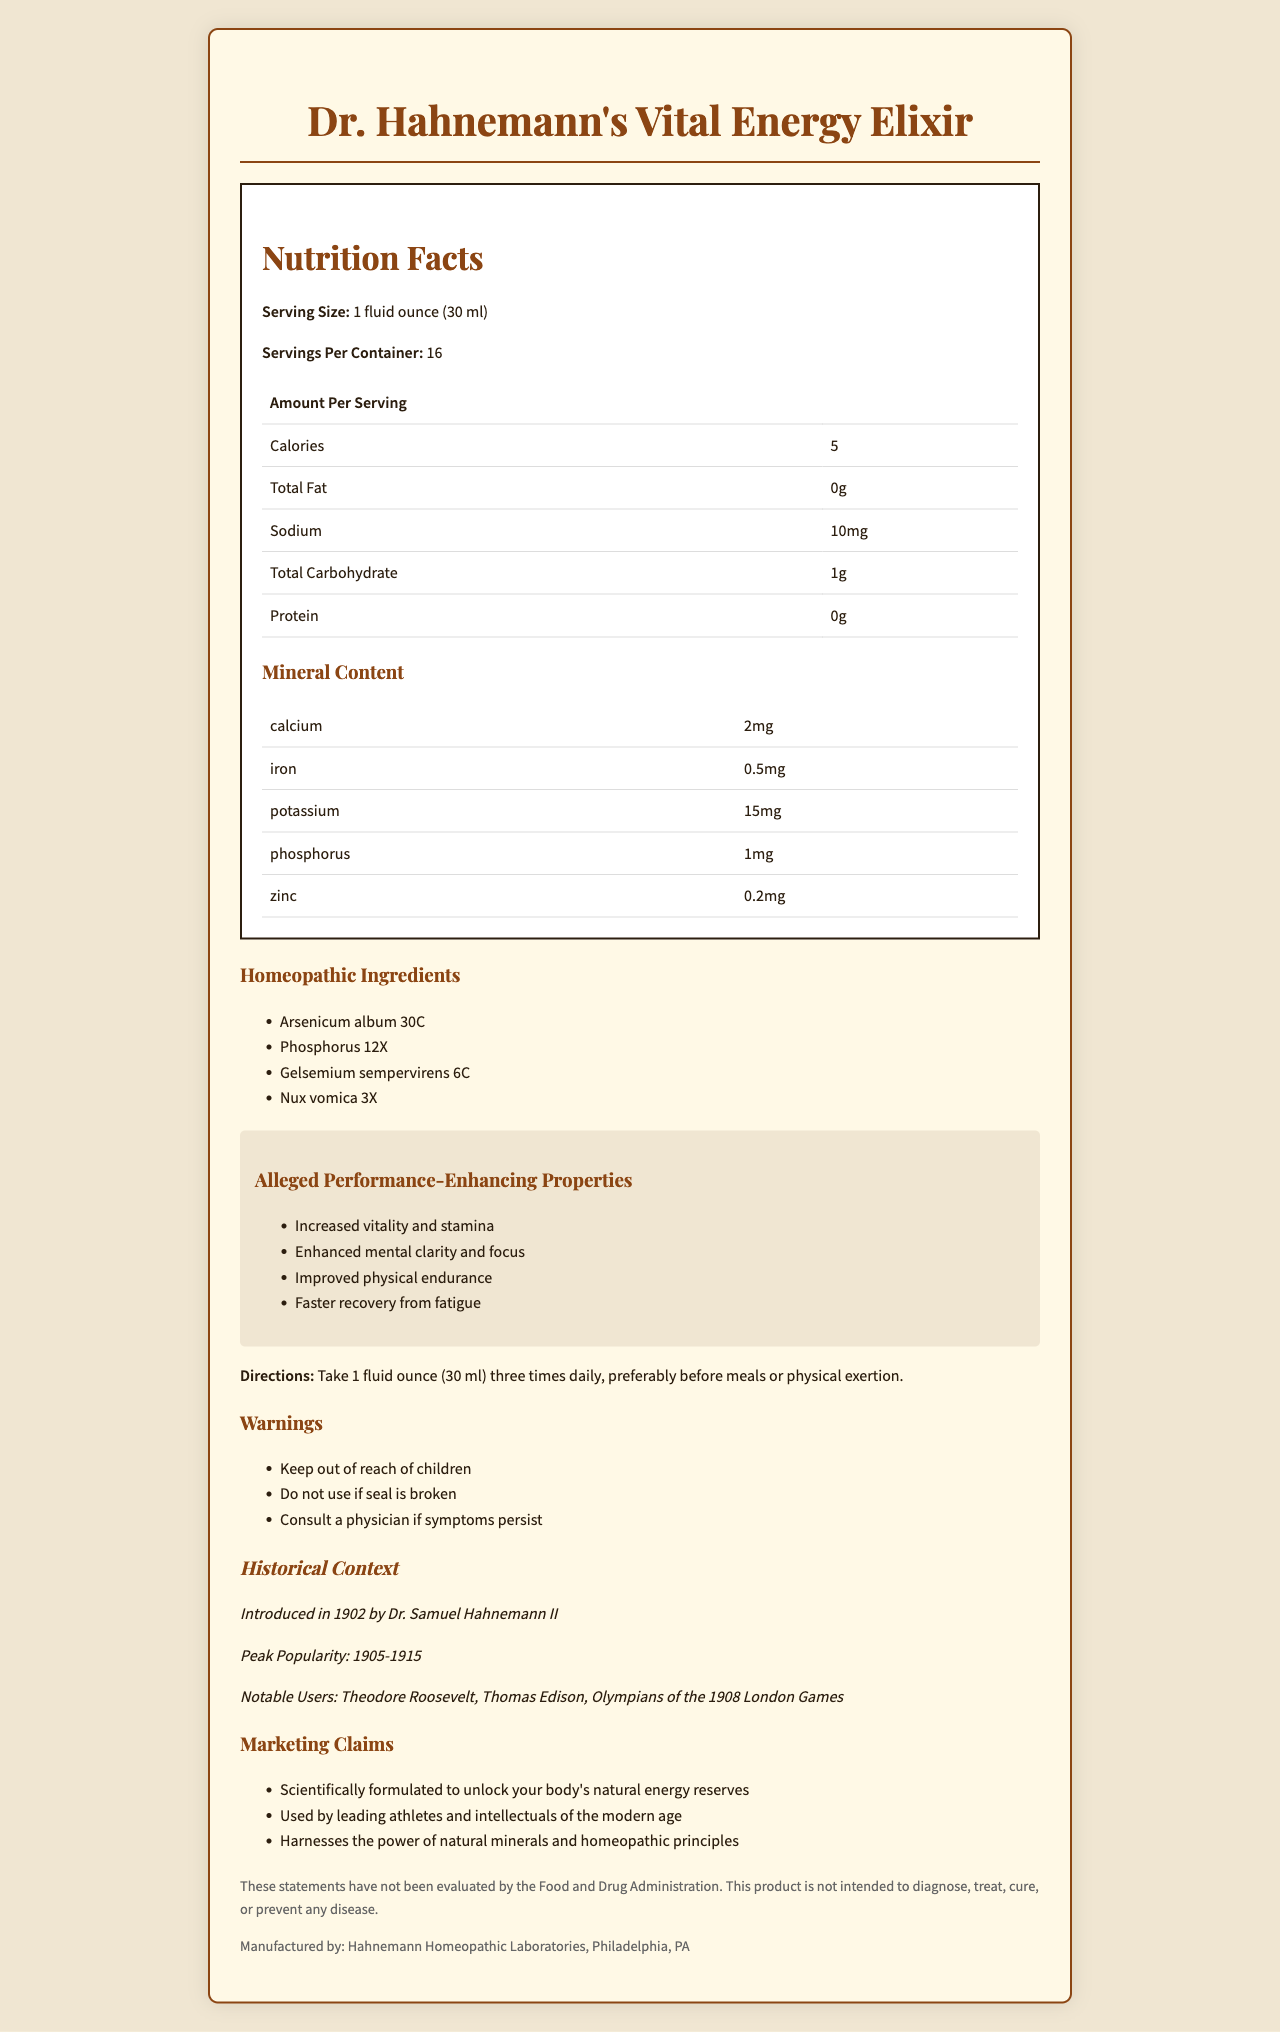what is the serving size of Dr. Hahnemann's Vital Energy Elixir? The serving size is listed under "Serving Size" in the Nutrition Facts section.
Answer: 1 fluid ounce (30 ml) how many calories are there per serving? The calories per serving are listed as 5 in the Nutrition Facts section.
Answer: 5 calories Name two minerals found in Dr. Hahnemann's Vital Energy Elixir. The minerals are listed under the "Mineral Content" section.
Answer: Calcium and Iron list two homeopathic ingredients in the elixir. The homeopathic ingredients are listed under "Homeopathic Ingredients".
Answer: Arsenicum album 30C, Phosphorus 12X what should you do if the seal is broken? This warning is listed under the "Warnings" section.
Answer: Do not use it who was the inventor of Dr. Hahnemann's Vital Energy Elixir? The inventor information is listed in the "Historical Context" section.
Answer: Dr. Samuel Hahnemann II what is the peak popularity period of the elixir? The peak popularity period is listed under the "Historical Context".
Answer: 1905-1915 What direction is given for taking the elixir? The directions are listed under the "Directions" section.
Answer: Take 1 fluid ounce (30 ml) three times daily, preferably before meals or physical exertion. which President was a notable user of the elixir? Listed under "Notable Users" in the "Historical Context".
Answer: Theodore Roosevelt True or False: The elixir claims to cure diseases. The disclaimer states that the product is not intended to diagnose, treat, cure, or prevent any disease.
Answer: False what are the alleged benefits of taking this elixir? A. Increased energy B. Loss of weight C. Enhanced mental clarity D. Better vision The alleged performance-enhancing properties are "Increased vitality and stamina" and "Enhanced mental clarity and focus".
Answer: A, C how many servings are there per container? A. 8 B. 12 C. 16 D. 24 The Nutrition Facts section lists servings per container as 16.
Answer: C summarize the main idea of the document. The document includes a detailed description of the elixir's nutritional and mineral content, homeopathic ingredients, alleged benefits, historical context, and warnings, along with marketing claims and usage directions.
Answer: Dr. Hahnemann's Vital Energy Elixir is a homeopathic product from the early 1900s that promises increased vitality, stamina, mental clarity, and physical endurance through a combination of minerals and homeopathic ingredients. The product was popular among notable figures such as Theodore Roosevelt and athletes from the 1908 Olympics. Specific usage instructions and warnings are provided, and a disclaimer states that it is not intended to diagnose, treat, cure, or prevent any disease. What was the cost of the elixir when it was first introduced? The document does not provide any information about the cost of the elixir when it was first introduced.
Answer: Not enough information 